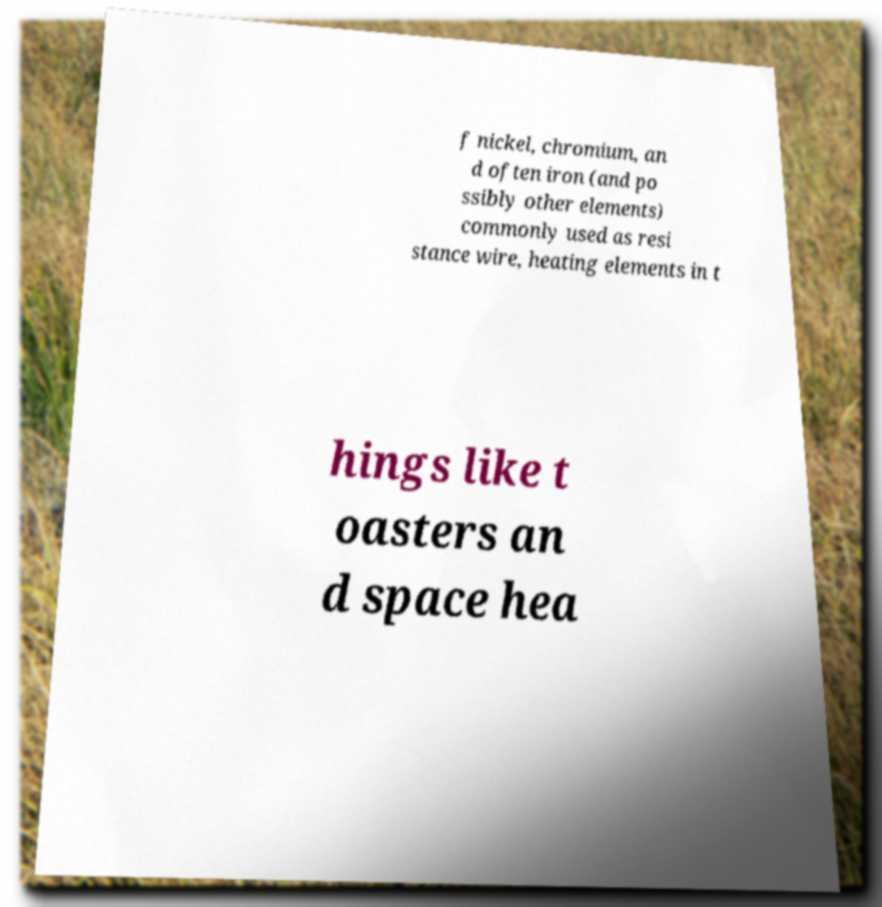Please identify and transcribe the text found in this image. f nickel, chromium, an d often iron (and po ssibly other elements) commonly used as resi stance wire, heating elements in t hings like t oasters an d space hea 